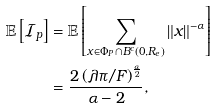<formula> <loc_0><loc_0><loc_500><loc_500>\mathbb { E } \left [ \mathcal { I } _ { p } \right ] & = \mathbb { E } \left [ \sum _ { x \in \Phi _ { P } \cap B ^ { c } ( 0 , R _ { e } ) } \| x \| ^ { - \alpha } \right ] \\ & = \frac { 2 \left ( \lambda \pi / F \right ) ^ { \frac { \alpha } { 2 } } } { \alpha - 2 } ,</formula> 